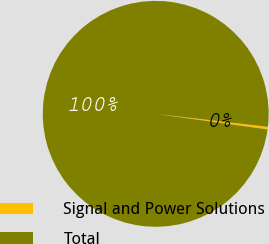<chart> <loc_0><loc_0><loc_500><loc_500><pie_chart><fcel>Signal and Power Solutions<fcel>Total<nl><fcel>0.37%<fcel>99.63%<nl></chart> 